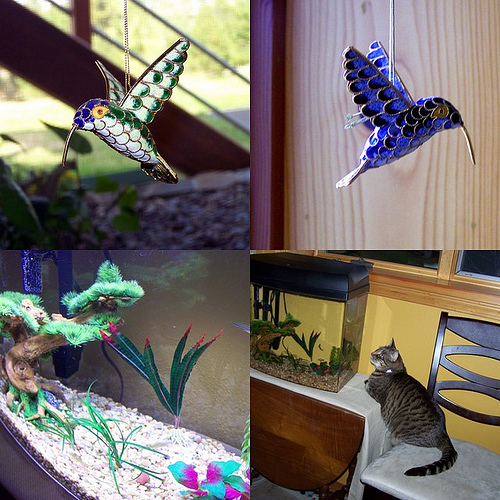What type of birds are in the top images? The top images do not depict real birds but instead show beautiful stained glass ornaments designed in the shape of what could be perceived as hummingbirds based on their long beaks and hovering posture. They are vibrant and decorative pieces, quite common as window hangings, as they capture and refract light exquisitely. 